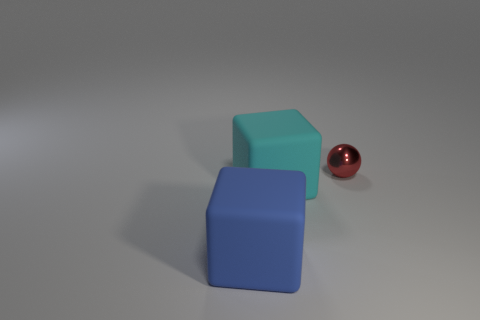There is a large block that is to the right of the thing that is in front of the large matte cube that is right of the blue object; what is it made of?
Your answer should be compact. Rubber. There is a cyan rubber thing; is it the same shape as the thing that is behind the cyan block?
Offer a very short reply. No. How many cyan rubber things are the same shape as the large blue rubber object?
Offer a terse response. 1. What is the shape of the red thing?
Ensure brevity in your answer.  Sphere. What is the size of the object that is behind the large matte thing on the right side of the blue rubber thing?
Provide a succinct answer. Small. How many things are small red balls or blue matte blocks?
Your response must be concise. 2. Is the shape of the blue object the same as the small red metal thing?
Give a very brief answer. No. Is there another cyan thing made of the same material as the large cyan object?
Make the answer very short. No. Are there any big blocks behind the large object that is in front of the cyan matte thing?
Your answer should be compact. Yes. Do the matte block on the left side of the cyan rubber thing and the cyan thing have the same size?
Ensure brevity in your answer.  Yes. 